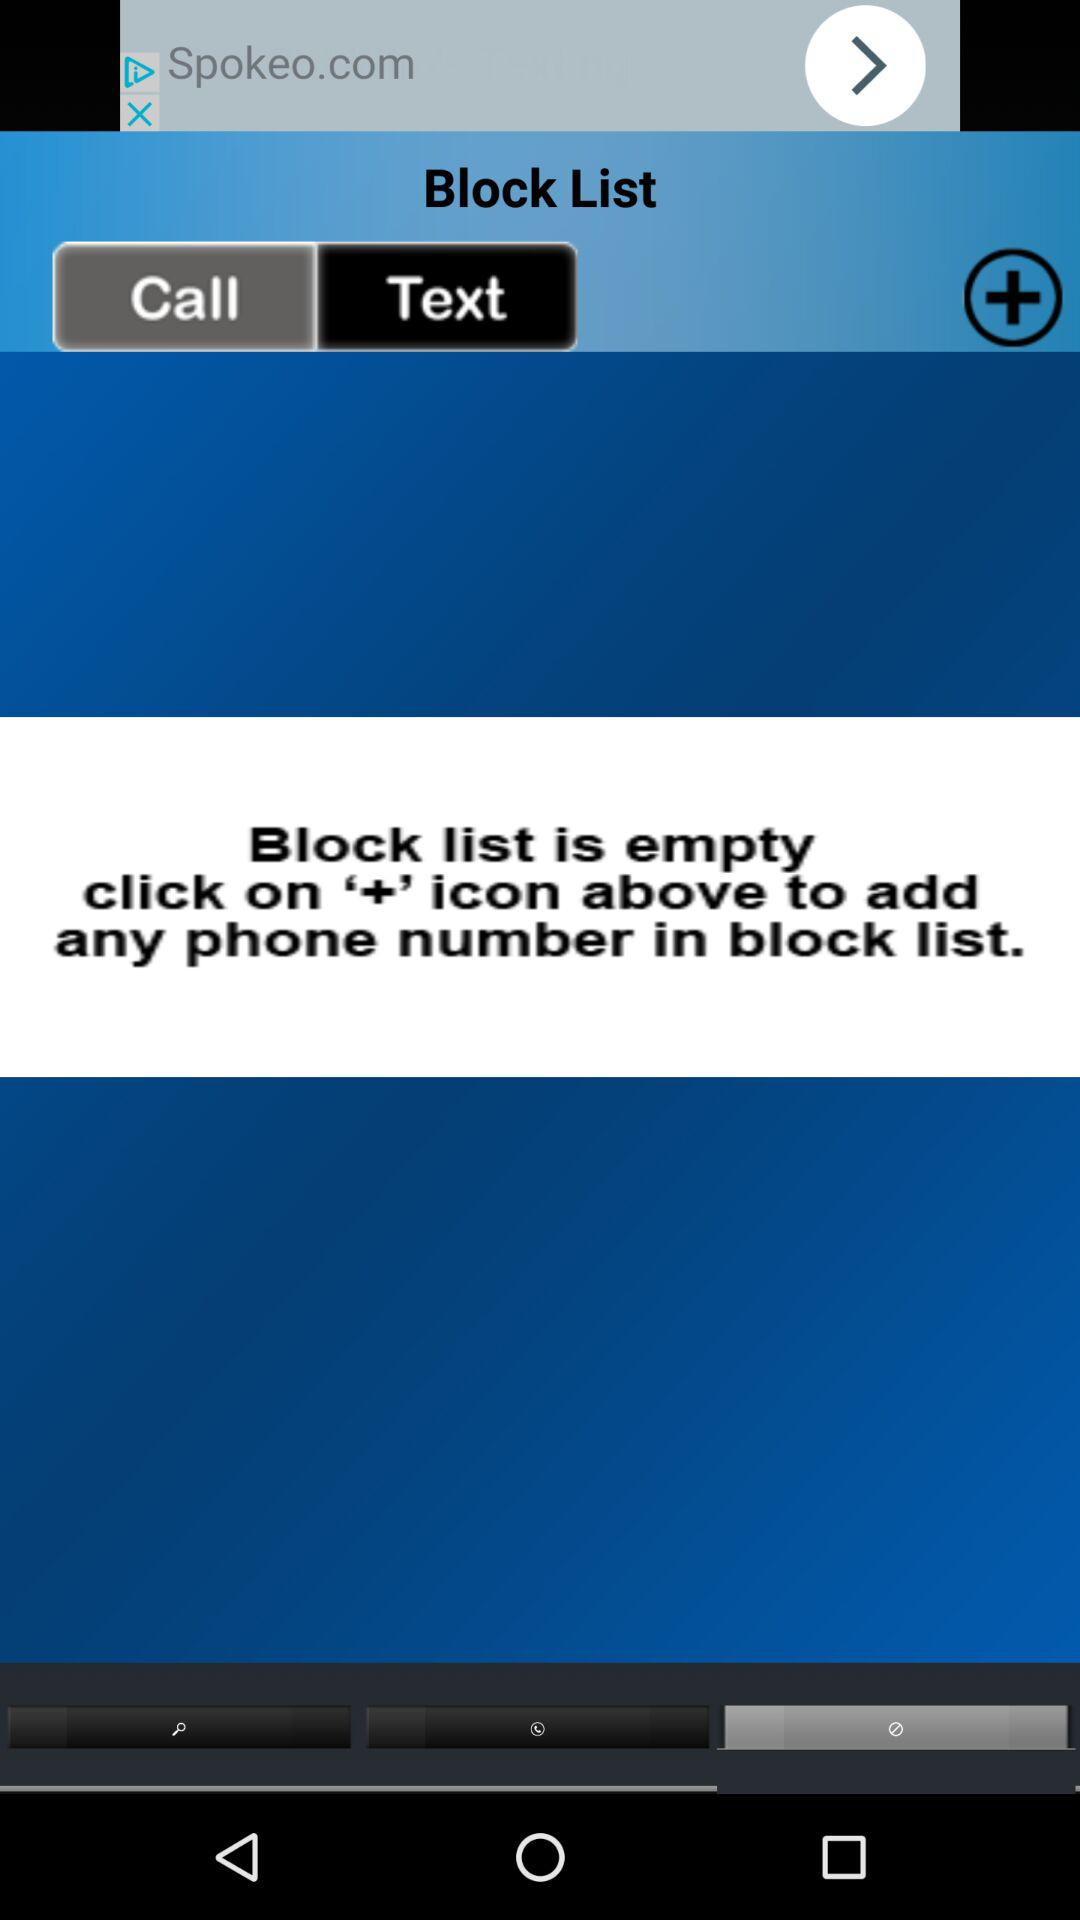What is to be added to the block list? It is the phone number that is to be added to the block list. 